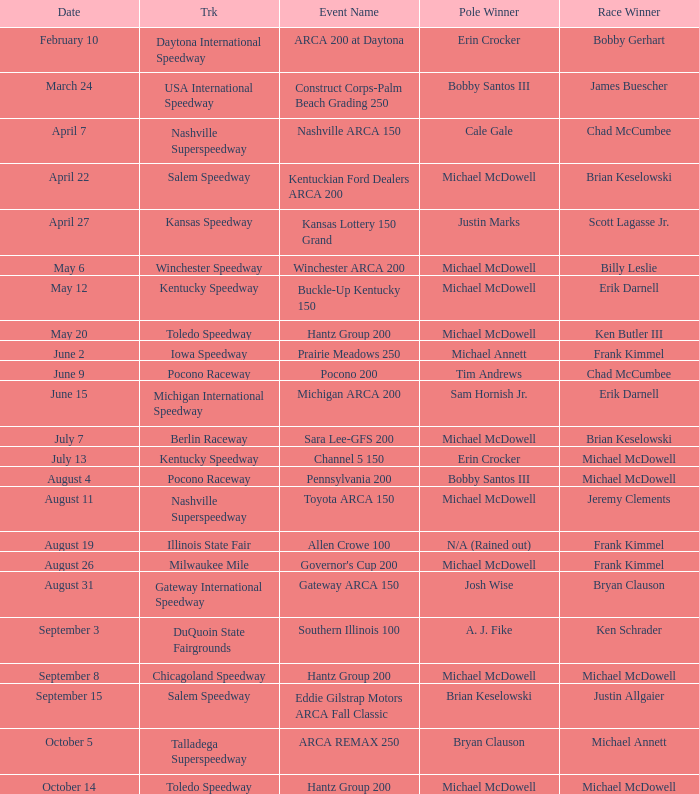Tell me the event name for michael mcdowell and billy leslie Winchester ARCA 200. 